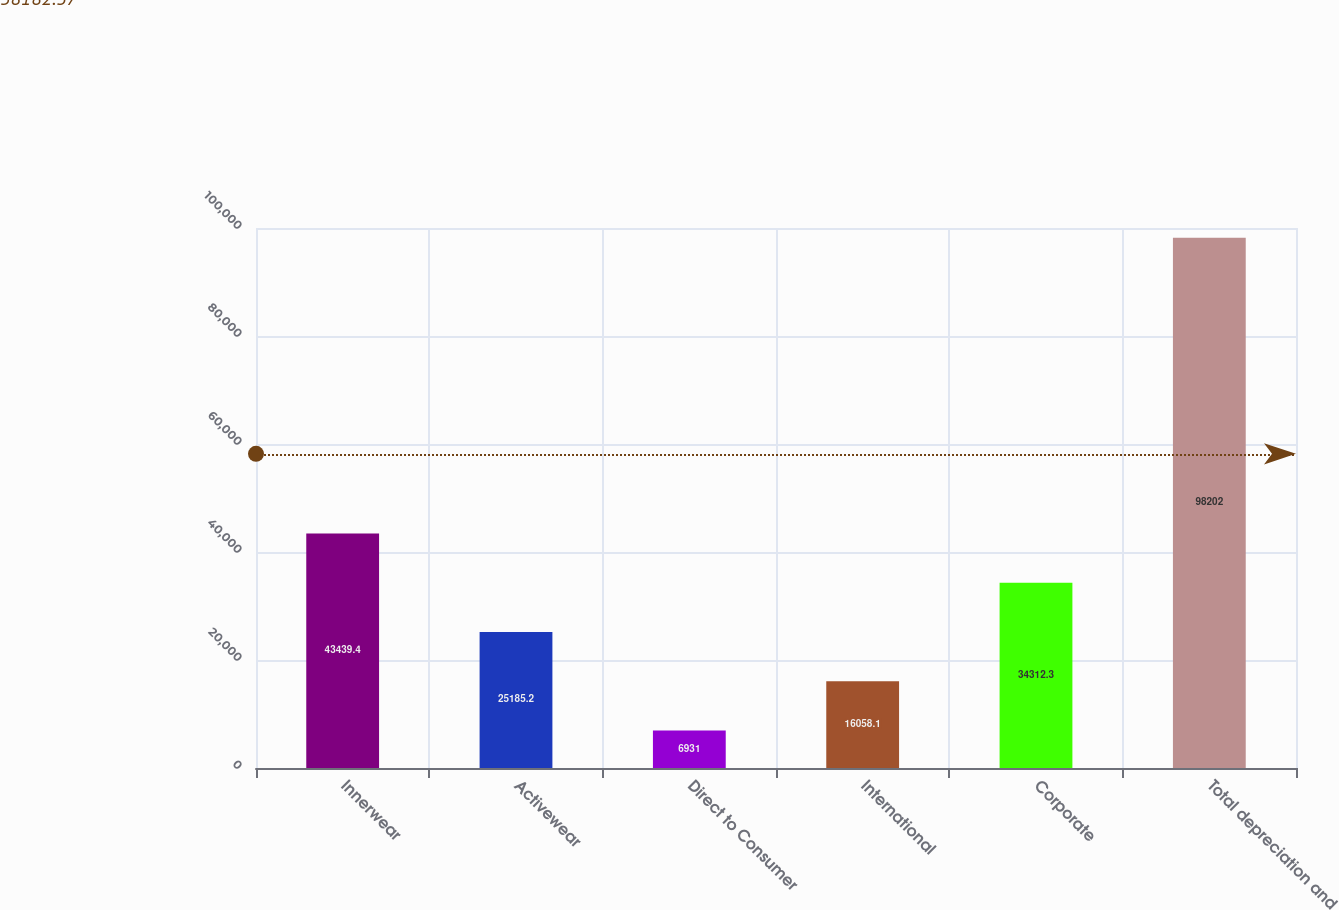Convert chart to OTSL. <chart><loc_0><loc_0><loc_500><loc_500><bar_chart><fcel>Innerwear<fcel>Activewear<fcel>Direct to Consumer<fcel>International<fcel>Corporate<fcel>Total depreciation and<nl><fcel>43439.4<fcel>25185.2<fcel>6931<fcel>16058.1<fcel>34312.3<fcel>98202<nl></chart> 